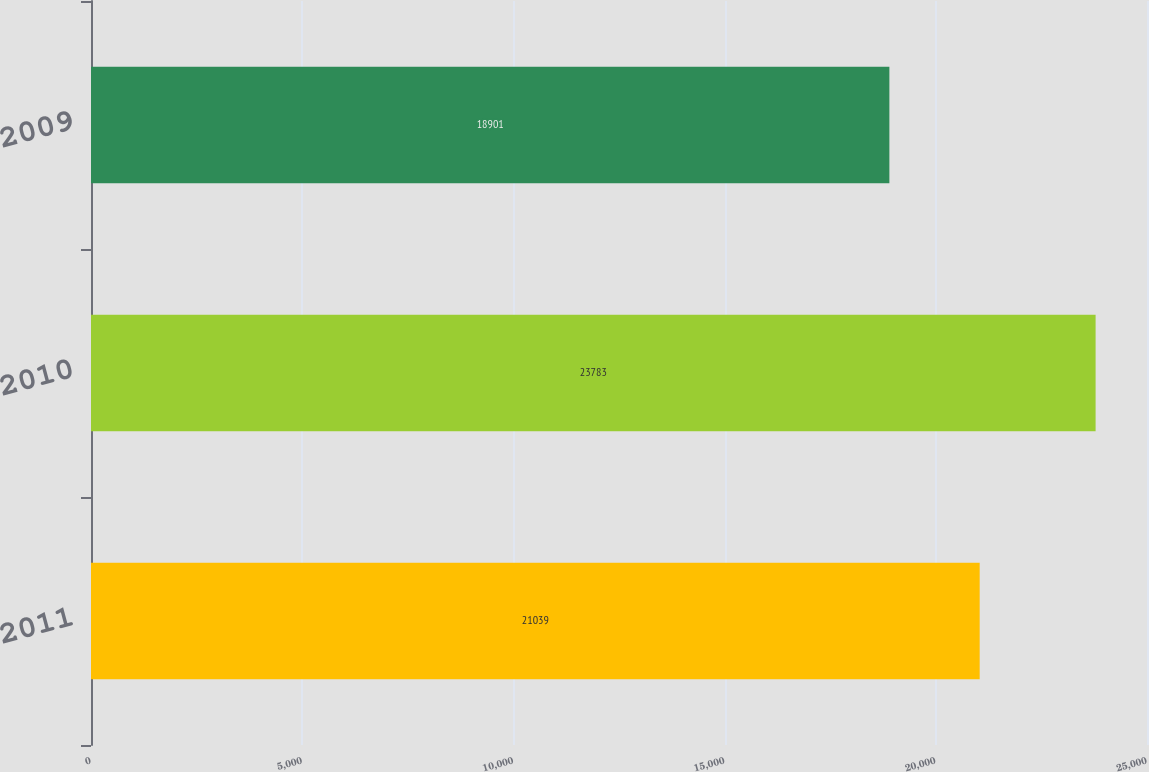<chart> <loc_0><loc_0><loc_500><loc_500><bar_chart><fcel>2011<fcel>2010<fcel>2009<nl><fcel>21039<fcel>23783<fcel>18901<nl></chart> 